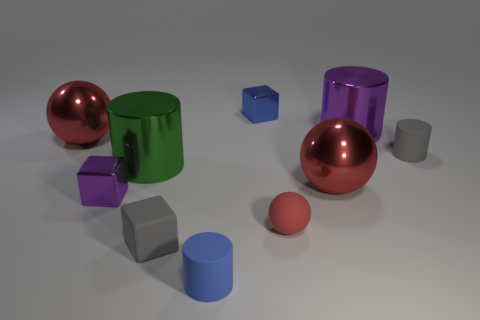What material is the small object that is the same color as the small rubber cube?
Provide a short and direct response. Rubber. How many other objects are there of the same size as the blue cylinder?
Your answer should be very brief. 5. What number of other things are the same color as the tiny matte sphere?
Provide a succinct answer. 2. What number of other objects are the same shape as the blue rubber object?
Ensure brevity in your answer.  3. Is the green cylinder the same size as the red rubber sphere?
Make the answer very short. No. Is there a big red rubber sphere?
Offer a terse response. No. Is there a green thing that has the same material as the green cylinder?
Offer a very short reply. No. There is a gray cylinder that is the same size as the blue cylinder; what material is it?
Ensure brevity in your answer.  Rubber. How many other purple metallic things are the same shape as the big purple thing?
Your answer should be very brief. 0. What is the size of the purple block that is made of the same material as the small blue cube?
Provide a succinct answer. Small. 